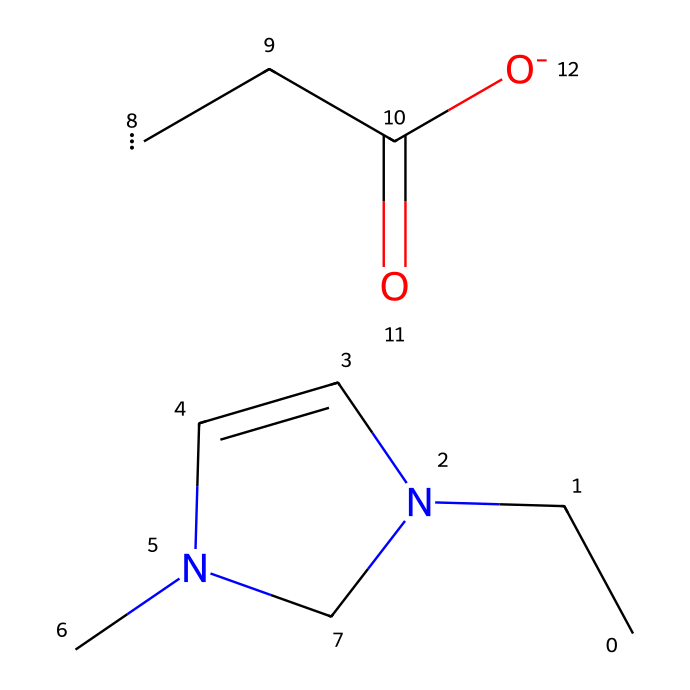How many nitrogen atoms are present in the structure? By examining the SMILES representation, we can identify the two nitrogen atoms in the imidazolium ring, making it evident that there are two nitrogen atoms in total.
Answer: 2 What is the predominant functional group in 1-ethyl-3-methylimidazolium acetate? Analyzing the structure reveals a carboxylate group (from the acetate) which is identifiable by the -C(=O)[O-] portion of the chemical.
Answer: carboxylate How many carbon atoms are there in total in this molecule? Counting the carbon atoms from the ethyl (2), methyl (1), and imidazolium (3) portions alongside the acetate (2) yields a total of 8 carbon atoms.
Answer: 8 What type of ionic liquid is represented by this structure? The structure reveals an imidazolium-based ionic liquid, which is characterized by its imidazole ring and ionic interactions.
Answer: imidazolium What is the charge of the acetate part in this ionic liquid? The acetate portion is represented as -C(=O)[O-], showing that it carries a negative charge due to the presence of the -O- that is negatively charged.
Answer: negative Which part of the structure indicates its use for wood preservation? The presence of the acetate group suggests its functionality and efficacy as a biocide in wood preservation, as acetate compounds are known for their protective properties against decay.
Answer: acetate group 